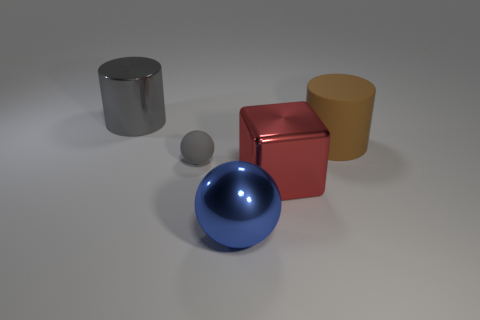Add 4 tiny green cylinders. How many objects exist? 9 Subtract all blue balls. How many balls are left? 1 Subtract 1 cylinders. How many cylinders are left? 1 Subtract 1 red blocks. How many objects are left? 4 Subtract all spheres. How many objects are left? 3 Subtract all yellow cubes. Subtract all gray balls. How many cubes are left? 1 Subtract all small gray metal blocks. Subtract all big brown matte cylinders. How many objects are left? 4 Add 5 brown objects. How many brown objects are left? 6 Add 2 big cylinders. How many big cylinders exist? 4 